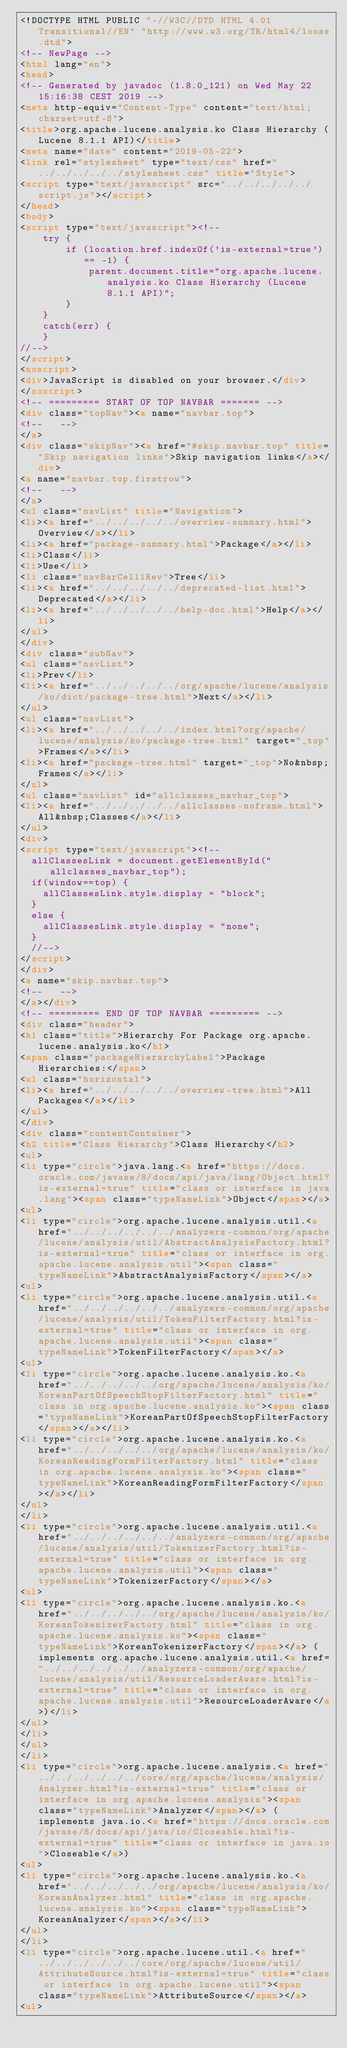<code> <loc_0><loc_0><loc_500><loc_500><_HTML_><!DOCTYPE HTML PUBLIC "-//W3C//DTD HTML 4.01 Transitional//EN" "http://www.w3.org/TR/html4/loose.dtd">
<!-- NewPage -->
<html lang="en">
<head>
<!-- Generated by javadoc (1.8.0_121) on Wed May 22 15:16:38 CEST 2019 -->
<meta http-equiv="Content-Type" content="text/html; charset=utf-8">
<title>org.apache.lucene.analysis.ko Class Hierarchy (Lucene 8.1.1 API)</title>
<meta name="date" content="2019-05-22">
<link rel="stylesheet" type="text/css" href="../../../../../stylesheet.css" title="Style">
<script type="text/javascript" src="../../../../../script.js"></script>
</head>
<body>
<script type="text/javascript"><!--
    try {
        if (location.href.indexOf('is-external=true') == -1) {
            parent.document.title="org.apache.lucene.analysis.ko Class Hierarchy (Lucene 8.1.1 API)";
        }
    }
    catch(err) {
    }
//-->
</script>
<noscript>
<div>JavaScript is disabled on your browser.</div>
</noscript>
<!-- ========= START OF TOP NAVBAR ======= -->
<div class="topNav"><a name="navbar.top">
<!--   -->
</a>
<div class="skipNav"><a href="#skip.navbar.top" title="Skip navigation links">Skip navigation links</a></div>
<a name="navbar.top.firstrow">
<!--   -->
</a>
<ul class="navList" title="Navigation">
<li><a href="../../../../../overview-summary.html">Overview</a></li>
<li><a href="package-summary.html">Package</a></li>
<li>Class</li>
<li>Use</li>
<li class="navBarCell1Rev">Tree</li>
<li><a href="../../../../../deprecated-list.html">Deprecated</a></li>
<li><a href="../../../../../help-doc.html">Help</a></li>
</ul>
</div>
<div class="subNav">
<ul class="navList">
<li>Prev</li>
<li><a href="../../../../../org/apache/lucene/analysis/ko/dict/package-tree.html">Next</a></li>
</ul>
<ul class="navList">
<li><a href="../../../../../index.html?org/apache/lucene/analysis/ko/package-tree.html" target="_top">Frames</a></li>
<li><a href="package-tree.html" target="_top">No&nbsp;Frames</a></li>
</ul>
<ul class="navList" id="allclasses_navbar_top">
<li><a href="../../../../../allclasses-noframe.html">All&nbsp;Classes</a></li>
</ul>
<div>
<script type="text/javascript"><!--
  allClassesLink = document.getElementById("allclasses_navbar_top");
  if(window==top) {
    allClassesLink.style.display = "block";
  }
  else {
    allClassesLink.style.display = "none";
  }
  //-->
</script>
</div>
<a name="skip.navbar.top">
<!--   -->
</a></div>
<!-- ========= END OF TOP NAVBAR ========= -->
<div class="header">
<h1 class="title">Hierarchy For Package org.apache.lucene.analysis.ko</h1>
<span class="packageHierarchyLabel">Package Hierarchies:</span>
<ul class="horizontal">
<li><a href="../../../../../overview-tree.html">All Packages</a></li>
</ul>
</div>
<div class="contentContainer">
<h2 title="Class Hierarchy">Class Hierarchy</h2>
<ul>
<li type="circle">java.lang.<a href="https://docs.oracle.com/javase/8/docs/api/java/lang/Object.html?is-external=true" title="class or interface in java.lang"><span class="typeNameLink">Object</span></a>
<ul>
<li type="circle">org.apache.lucene.analysis.util.<a href="../../../../../../analyzers-common/org/apache/lucene/analysis/util/AbstractAnalysisFactory.html?is-external=true" title="class or interface in org.apache.lucene.analysis.util"><span class="typeNameLink">AbstractAnalysisFactory</span></a>
<ul>
<li type="circle">org.apache.lucene.analysis.util.<a href="../../../../../../analyzers-common/org/apache/lucene/analysis/util/TokenFilterFactory.html?is-external=true" title="class or interface in org.apache.lucene.analysis.util"><span class="typeNameLink">TokenFilterFactory</span></a>
<ul>
<li type="circle">org.apache.lucene.analysis.ko.<a href="../../../../../org/apache/lucene/analysis/ko/KoreanPartOfSpeechStopFilterFactory.html" title="class in org.apache.lucene.analysis.ko"><span class="typeNameLink">KoreanPartOfSpeechStopFilterFactory</span></a></li>
<li type="circle">org.apache.lucene.analysis.ko.<a href="../../../../../org/apache/lucene/analysis/ko/KoreanReadingFormFilterFactory.html" title="class in org.apache.lucene.analysis.ko"><span class="typeNameLink">KoreanReadingFormFilterFactory</span></a></li>
</ul>
</li>
<li type="circle">org.apache.lucene.analysis.util.<a href="../../../../../../analyzers-common/org/apache/lucene/analysis/util/TokenizerFactory.html?is-external=true" title="class or interface in org.apache.lucene.analysis.util"><span class="typeNameLink">TokenizerFactory</span></a>
<ul>
<li type="circle">org.apache.lucene.analysis.ko.<a href="../../../../../org/apache/lucene/analysis/ko/KoreanTokenizerFactory.html" title="class in org.apache.lucene.analysis.ko"><span class="typeNameLink">KoreanTokenizerFactory</span></a> (implements org.apache.lucene.analysis.util.<a href="../../../../../../analyzers-common/org/apache/lucene/analysis/util/ResourceLoaderAware.html?is-external=true" title="class or interface in org.apache.lucene.analysis.util">ResourceLoaderAware</a>)</li>
</ul>
</li>
</ul>
</li>
<li type="circle">org.apache.lucene.analysis.<a href="../../../../../../core/org/apache/lucene/analysis/Analyzer.html?is-external=true" title="class or interface in org.apache.lucene.analysis"><span class="typeNameLink">Analyzer</span></a> (implements java.io.<a href="https://docs.oracle.com/javase/8/docs/api/java/io/Closeable.html?is-external=true" title="class or interface in java.io">Closeable</a>)
<ul>
<li type="circle">org.apache.lucene.analysis.ko.<a href="../../../../../org/apache/lucene/analysis/ko/KoreanAnalyzer.html" title="class in org.apache.lucene.analysis.ko"><span class="typeNameLink">KoreanAnalyzer</span></a></li>
</ul>
</li>
<li type="circle">org.apache.lucene.util.<a href="../../../../../../core/org/apache/lucene/util/AttributeSource.html?is-external=true" title="class or interface in org.apache.lucene.util"><span class="typeNameLink">AttributeSource</span></a>
<ul></code> 